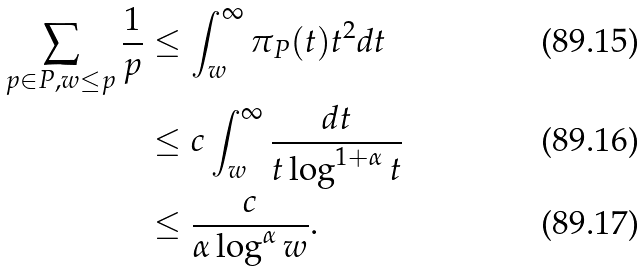<formula> <loc_0><loc_0><loc_500><loc_500>\sum _ { p \in P , w \leq p } \frac { 1 } { p } & \leq \int _ { w } ^ { \infty } { \pi _ { P } ( t ) } { t ^ { 2 } } d t \\ & \leq c \int _ { w } ^ { \infty } \frac { d t } { t \log ^ { 1 + \alpha } { t } } \\ & \leq \frac { c } { \alpha \log ^ { \alpha } { w } } .</formula> 